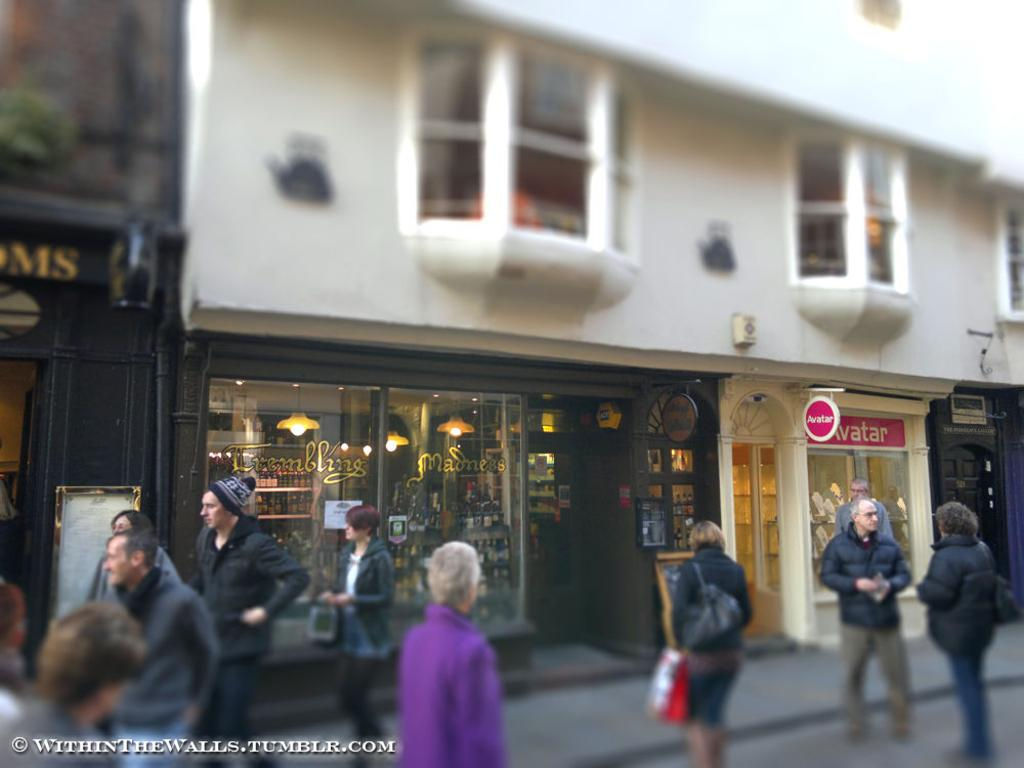What are the people in the image doing? The people in the image are standing and walking. What is the location of the people in the image? The people are in front of a building. What type of building is it? The building appears to be a store. Where does the scene take place? The scene takes place on a road. Can you see any toes sticking out of the store in the image? There is no indication of toes or any body parts sticking out of the store in the image. 